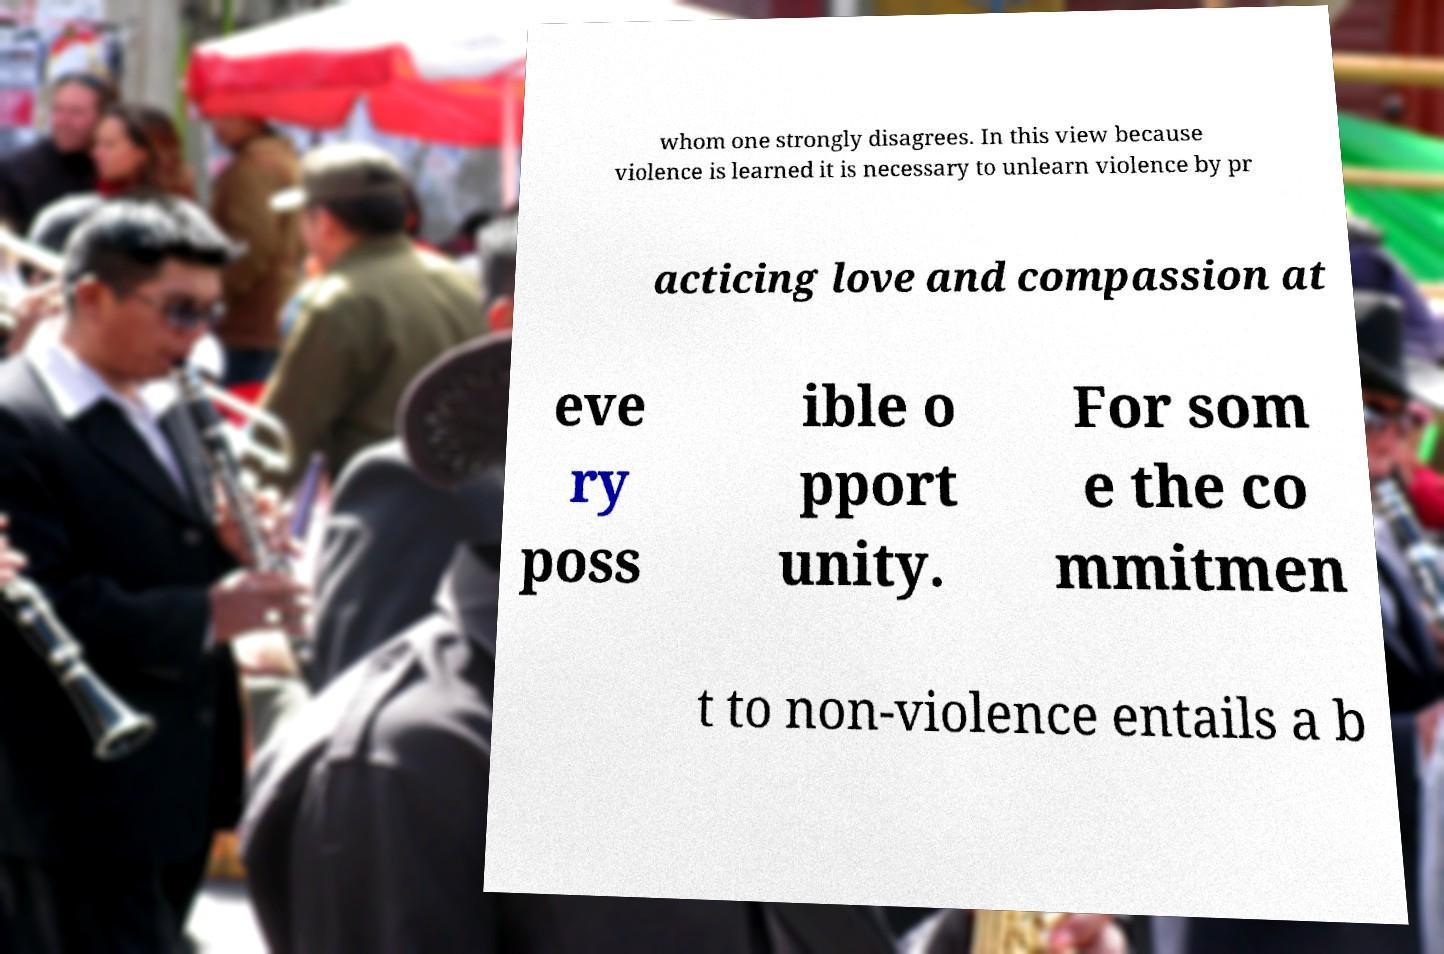Please read and relay the text visible in this image. What does it say? whom one strongly disagrees. In this view because violence is learned it is necessary to unlearn violence by pr acticing love and compassion at eve ry poss ible o pport unity. For som e the co mmitmen t to non-violence entails a b 